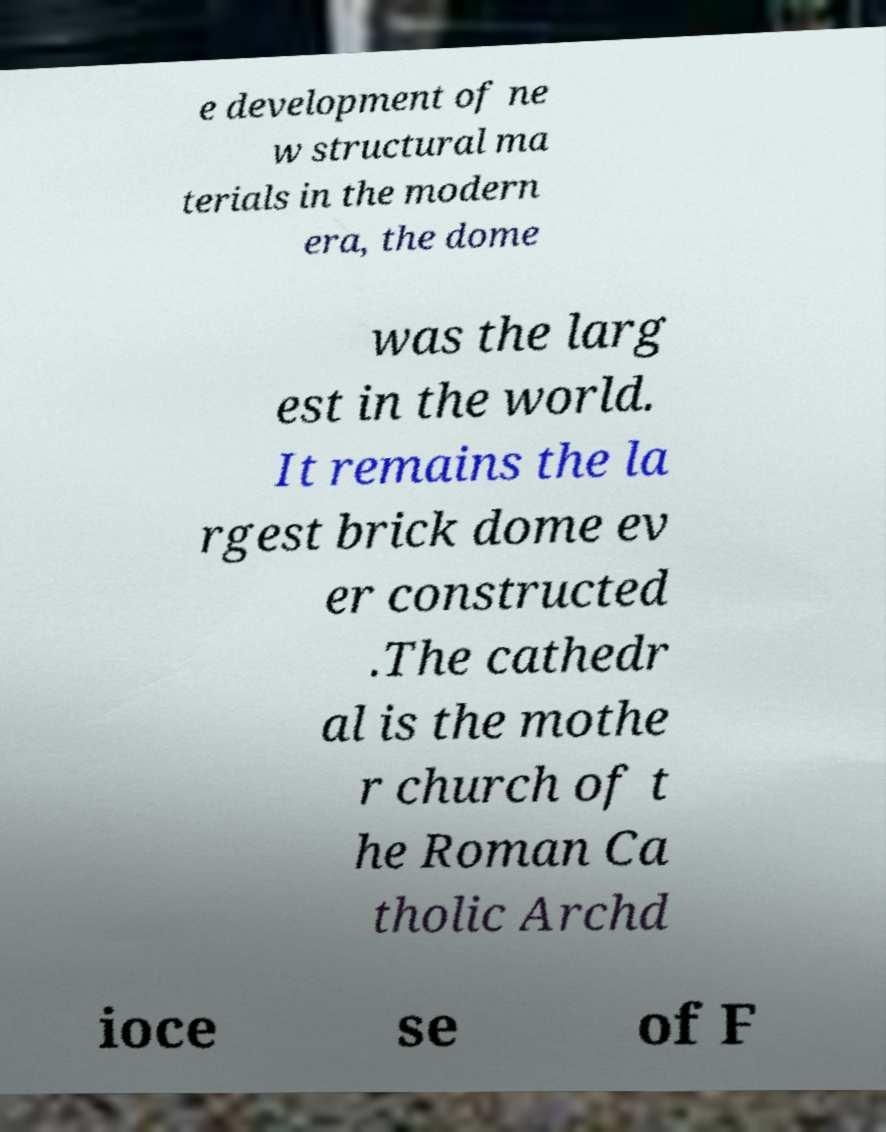Could you assist in decoding the text presented in this image and type it out clearly? e development of ne w structural ma terials in the modern era, the dome was the larg est in the world. It remains the la rgest brick dome ev er constructed .The cathedr al is the mothe r church of t he Roman Ca tholic Archd ioce se of F 